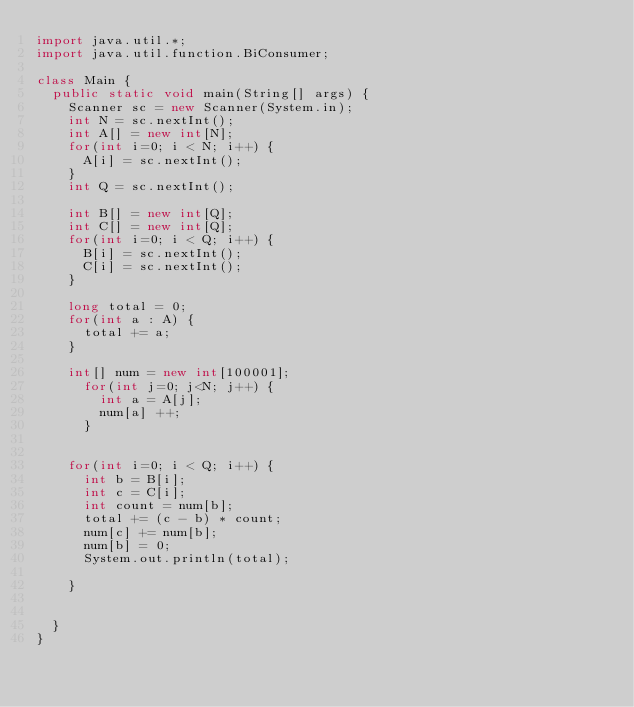<code> <loc_0><loc_0><loc_500><loc_500><_Java_>import java.util.*;
import java.util.function.BiConsumer;

class Main {
	public static void main(String[] args) {
		Scanner sc = new Scanner(System.in);
		int N = sc.nextInt();
		int A[] = new int[N];
		for(int i=0; i < N; i++) {
			A[i] = sc.nextInt();
		}
		int Q = sc.nextInt();
		
		int B[] = new int[Q];
		int C[] = new int[Q];
		for(int i=0; i < Q; i++) {
			B[i] = sc.nextInt();
			C[i] = sc.nextInt();
		}
		
		long total = 0;
		for(int a : A) {
			total += a;
		}
		
		int[] num = new int[100001];
			for(int j=0; j<N; j++) {
				int a = A[j];
				num[a] ++;
			}
		
		
		for(int i=0; i < Q; i++) {
			int b = B[i];
			int c = C[i];
			int count = num[b];
			total += (c - b) * count;
			num[c] += num[b];
			num[b] = 0;			
			System.out.println(total);
	
		}

		
	}
}
</code> 